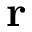Convert formula to latex. <formula><loc_0><loc_0><loc_500><loc_500>{ r }</formula> 